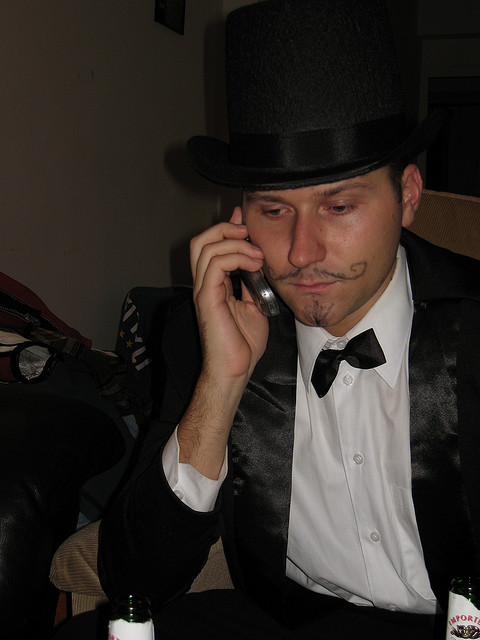What kind of phone is he using?
A. cellular
B. pay
C. rotary
D. landline
Answer with the option's letter from the given choices directly. The individual in the image is using a cellular phone, which can be identified by the size, shape, and the visible antenna. Option A is correct. Cellular phones came into widespread use after the early 1990s and are characterized by their mobility, allowing users to make calls without being tethered to a fixed location, unlike landline phones. 